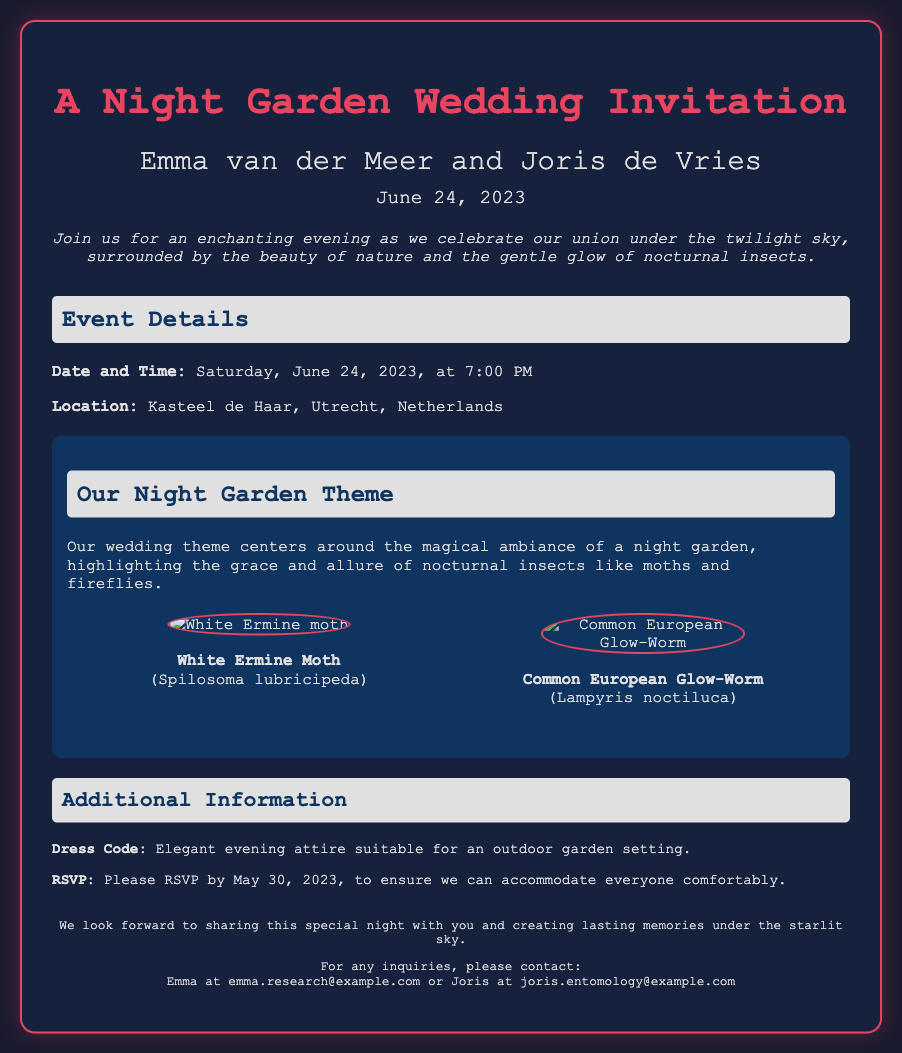What is the name of the couple getting married? The document states the couple's names prominently at the top of the invitation.
Answer: Emma van der Meer and Joris de Vries What is the wedding date? The date is clearly highlighted in the invitation details section.
Answer: June 24, 2023 Where is the wedding taking place? The location is mentioned under the event details in the document.
Answer: Kasteel de Haar, Utrecht, Netherlands What is the dress code for the wedding? The dress code is specified in the additional information section of the invitation.
Answer: Elegant evening attire What is the theme of the wedding? The theme is described in the section dedicated to the night garden theme.
Answer: Night Garden Theme What insects are highlighted in the wedding invitation? The document lists specific nocturnal insects as part of the wedding theme.
Answer: White Ermine Moth and Common European Glow-Worm What is the RSVP deadline? The RSVP deadline is provided in the additional information section of the invitation.
Answer: May 30, 2023 What time does the wedding start? The time of the event is explicitly stated in the event details of the invitation.
Answer: 7:00 PM What type of atmosphere is the couple aiming for? The introduction of the invitation describes the ambiance they wish to create.
Answer: Enchanting evening under the twilight sky 